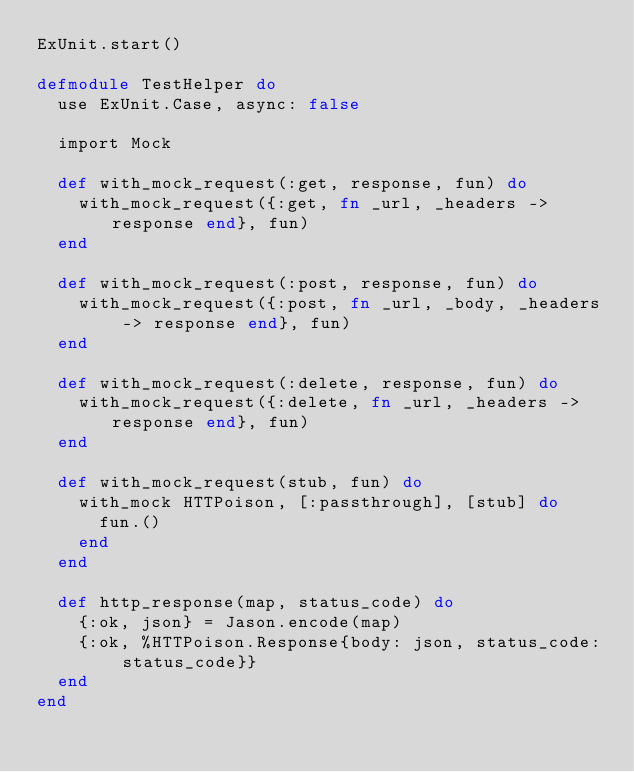<code> <loc_0><loc_0><loc_500><loc_500><_Elixir_>ExUnit.start()

defmodule TestHelper do
  use ExUnit.Case, async: false

  import Mock

  def with_mock_request(:get, response, fun) do
    with_mock_request({:get, fn _url, _headers -> response end}, fun)
  end

  def with_mock_request(:post, response, fun) do
    with_mock_request({:post, fn _url, _body, _headers -> response end}, fun)
  end

  def with_mock_request(:delete, response, fun) do
    with_mock_request({:delete, fn _url, _headers -> response end}, fun)
  end

  def with_mock_request(stub, fun) do
    with_mock HTTPoison, [:passthrough], [stub] do
      fun.()
    end
  end

  def http_response(map, status_code) do
    {:ok, json} = Jason.encode(map)
    {:ok, %HTTPoison.Response{body: json, status_code: status_code}}
  end
end
</code> 